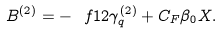Convert formula to latex. <formula><loc_0><loc_0><loc_500><loc_500>B ^ { ( 2 ) } = - \ f { 1 } { 2 } \gamma _ { q } ^ { ( 2 ) } + C _ { F } \beta _ { 0 } X .</formula> 